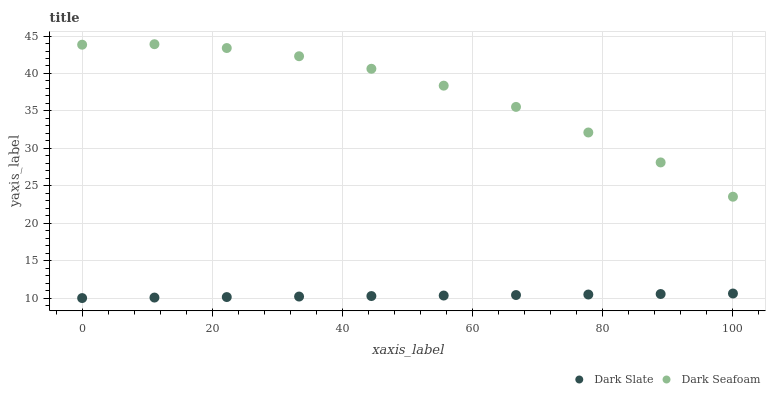Does Dark Slate have the minimum area under the curve?
Answer yes or no. Yes. Does Dark Seafoam have the maximum area under the curve?
Answer yes or no. Yes. Does Dark Seafoam have the minimum area under the curve?
Answer yes or no. No. Is Dark Slate the smoothest?
Answer yes or no. Yes. Is Dark Seafoam the roughest?
Answer yes or no. Yes. Is Dark Seafoam the smoothest?
Answer yes or no. No. Does Dark Slate have the lowest value?
Answer yes or no. Yes. Does Dark Seafoam have the lowest value?
Answer yes or no. No. Does Dark Seafoam have the highest value?
Answer yes or no. Yes. Is Dark Slate less than Dark Seafoam?
Answer yes or no. Yes. Is Dark Seafoam greater than Dark Slate?
Answer yes or no. Yes. Does Dark Slate intersect Dark Seafoam?
Answer yes or no. No. 